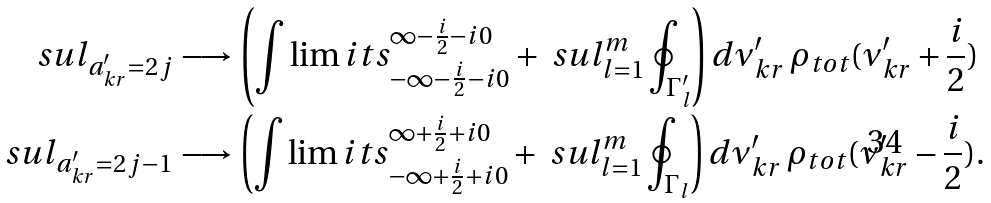<formula> <loc_0><loc_0><loc_500><loc_500>\ s u l _ { a ^ { \prime } _ { k r } = 2 j } & \longrightarrow \left ( \int \lim i t s _ { - \infty - \frac { i } { 2 } - i 0 } ^ { \infty - \frac { i } { 2 } - i 0 } + \ s u l _ { l = 1 } ^ { m } \oint _ { \Gamma ^ { \prime } _ { l } } \right ) d \nu ^ { \prime } _ { k r } \, \rho _ { t o t } ( \nu ^ { \prime } _ { k r } + \frac { i } { 2 } ) \\ \ s u l _ { a ^ { \prime } _ { k r } = { 2 j - 1 } } & \longrightarrow \left ( \int \lim i t s _ { - \infty + \frac { i } { 2 } + i 0 } ^ { \infty + \frac { i } { 2 } + i 0 } + \ s u l _ { l = 1 } ^ { m } \oint _ { \Gamma _ { l } } \right ) d \nu ^ { \prime } _ { k r } \, \rho _ { t o t } ( \nu ^ { \prime } _ { k r } - \frac { i } { 2 } ) .</formula> 